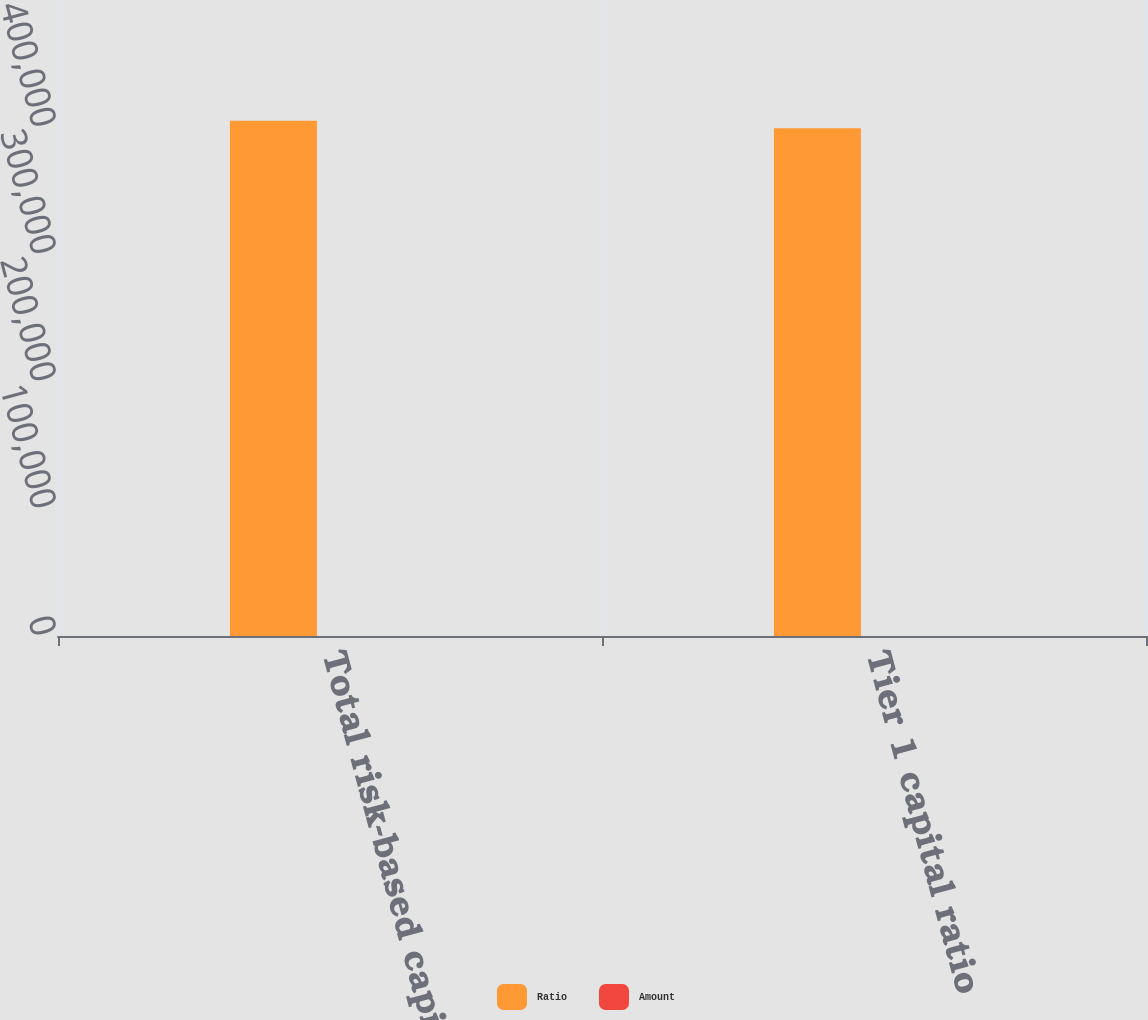<chart> <loc_0><loc_0><loc_500><loc_500><stacked_bar_chart><ecel><fcel>Total risk-based capital ratio<fcel>Tier 1 capital ratio<nl><fcel>Ratio<fcel>405000<fcel>399187<nl><fcel>Amount<fcel>92.5<fcel>22.8<nl></chart> 